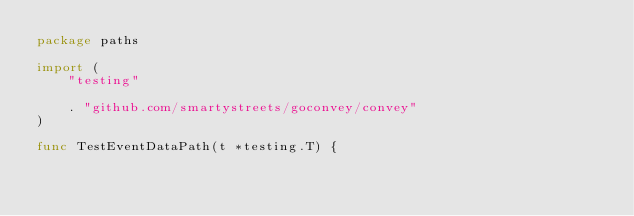<code> <loc_0><loc_0><loc_500><loc_500><_Go_>package paths

import (
	"testing"

	. "github.com/smartystreets/goconvey/convey"
)

func TestEventDataPath(t *testing.T) {
</code> 